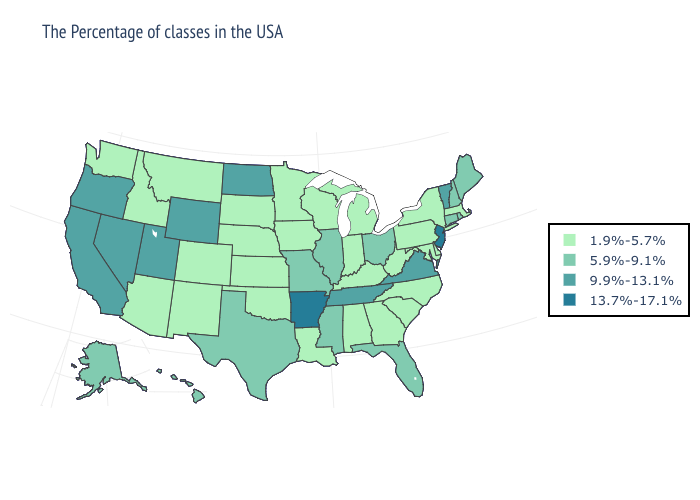Is the legend a continuous bar?
Keep it brief. No. What is the value of Colorado?
Be succinct. 1.9%-5.7%. What is the lowest value in states that border South Dakota?
Short answer required. 1.9%-5.7%. Does Vermont have the lowest value in the Northeast?
Short answer required. No. Among the states that border South Dakota , does Iowa have the highest value?
Quick response, please. No. Does Wisconsin have the lowest value in the USA?
Concise answer only. Yes. What is the value of North Carolina?
Give a very brief answer. 1.9%-5.7%. Name the states that have a value in the range 5.9%-9.1%?
Keep it brief. Maine, Rhode Island, New Hampshire, Connecticut, Ohio, Florida, Illinois, Mississippi, Missouri, Texas, Alaska, Hawaii. What is the lowest value in the USA?
Answer briefly. 1.9%-5.7%. What is the value of Illinois?
Keep it brief. 5.9%-9.1%. Which states have the lowest value in the South?
Concise answer only. Delaware, Maryland, North Carolina, South Carolina, West Virginia, Georgia, Kentucky, Alabama, Louisiana, Oklahoma. What is the highest value in states that border Rhode Island?
Concise answer only. 5.9%-9.1%. What is the value of South Carolina?
Answer briefly. 1.9%-5.7%. How many symbols are there in the legend?
Answer briefly. 4. What is the value of Georgia?
Write a very short answer. 1.9%-5.7%. 